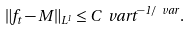Convert formula to latex. <formula><loc_0><loc_0><loc_500><loc_500>\| f _ { t } - M \| _ { L ^ { 1 } } \leq C _ { \ } v a r t ^ { - 1 / \ v a r } .</formula> 